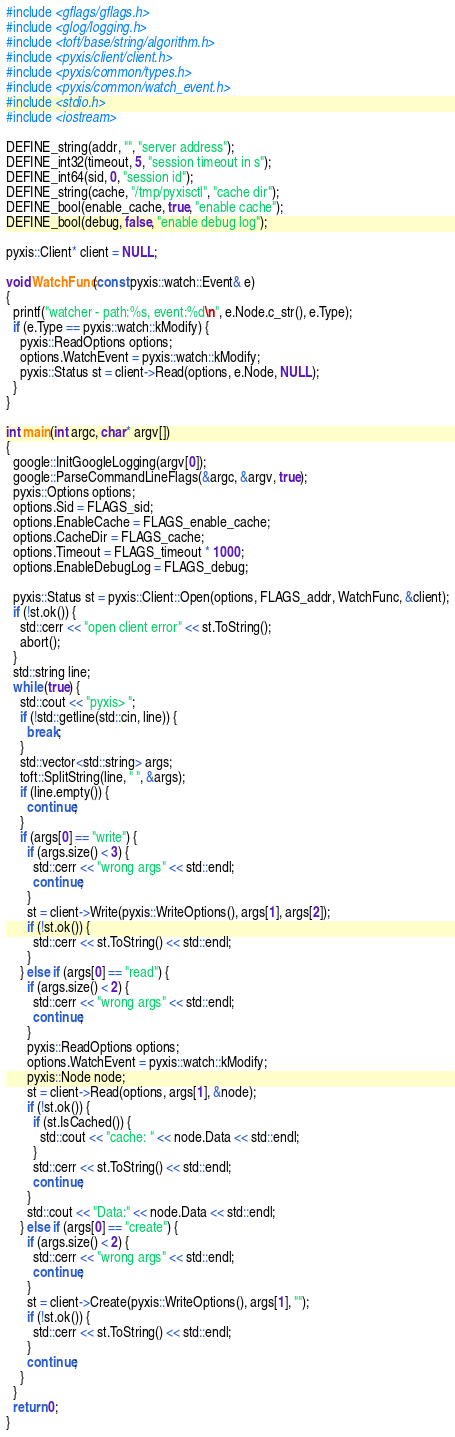<code> <loc_0><loc_0><loc_500><loc_500><_C++_>#include <gflags/gflags.h>
#include <glog/logging.h>
#include <toft/base/string/algorithm.h>
#include <pyxis/client/client.h>
#include <pyxis/common/types.h>
#include <pyxis/common/watch_event.h>
#include <stdio.h>
#include <iostream>

DEFINE_string(addr, "", "server address");
DEFINE_int32(timeout, 5, "session timeout in s");
DEFINE_int64(sid, 0, "session id");
DEFINE_string(cache, "/tmp/pyxisctl", "cache dir");
DEFINE_bool(enable_cache, true, "enable cache");
DEFINE_bool(debug, false, "enable debug log");

pyxis::Client* client = NULL;

void WatchFunc(const pyxis::watch::Event& e)
{
  printf("watcher - path:%s, event:%d\n", e.Node.c_str(), e.Type);
  if (e.Type == pyxis::watch::kModify) {
    pyxis::ReadOptions options;
    options.WatchEvent = pyxis::watch::kModify;
    pyxis::Status st = client->Read(options, e.Node, NULL);
  }
}

int main(int argc, char* argv[])
{
  google::InitGoogleLogging(argv[0]);
  google::ParseCommandLineFlags(&argc, &argv, true);
  pyxis::Options options;
  options.Sid = FLAGS_sid;
  options.EnableCache = FLAGS_enable_cache;
  options.CacheDir = FLAGS_cache;
  options.Timeout = FLAGS_timeout * 1000;
  options.EnableDebugLog = FLAGS_debug;

  pyxis::Status st = pyxis::Client::Open(options, FLAGS_addr, WatchFunc, &client);
  if (!st.ok()) {
    std::cerr << "open client error" << st.ToString();
    abort();
  }
  std::string line;
  while (true) {
    std::cout << "pyxis> ";
    if (!std::getline(std::cin, line)) {
      break;
    }
    std::vector<std::string> args;
    toft::SplitString(line, " ", &args);
    if (line.empty()) {
      continue;
    }
    if (args[0] == "write") {
      if (args.size() < 3) {
        std::cerr << "wrong args" << std::endl;
        continue;
      }
      st = client->Write(pyxis::WriteOptions(), args[1], args[2]);
      if (!st.ok()) {
        std::cerr << st.ToString() << std::endl;
      }
    } else if (args[0] == "read") {
      if (args.size() < 2) {
        std::cerr << "wrong args" << std::endl;
        continue;
      }
      pyxis::ReadOptions options;
      options.WatchEvent = pyxis::watch::kModify;
      pyxis::Node node;
      st = client->Read(options, args[1], &node);
      if (!st.ok()) {
        if (st.IsCached()) {
          std::cout << "cache: " << node.Data << std::endl;
        }
        std::cerr << st.ToString() << std::endl;
        continue;
      }
      std::cout << "Data:" << node.Data << std::endl;
    } else if (args[0] == "create") {
      if (args.size() < 2) {
        std::cerr << "wrong args" << std::endl;
        continue;
      }
      st = client->Create(pyxis::WriteOptions(), args[1], "");
      if (!st.ok()) {
        std::cerr << st.ToString() << std::endl;
      }
      continue;
    }
  }
  return 0;
}
</code> 